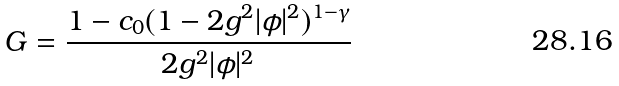Convert formula to latex. <formula><loc_0><loc_0><loc_500><loc_500>G = \frac { 1 - c _ { 0 } ( 1 - 2 g ^ { 2 } | \phi | ^ { 2 } ) ^ { 1 - \gamma } } { 2 g ^ { 2 } | \phi | ^ { 2 } }</formula> 